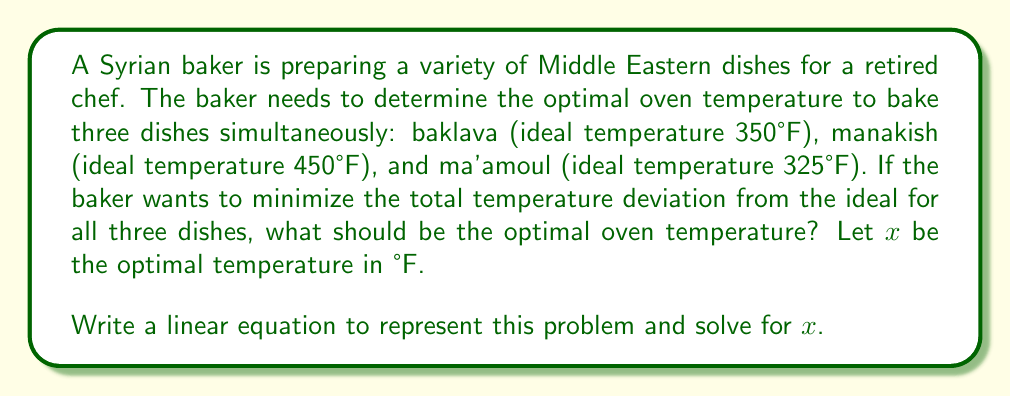Can you solve this math problem? Let's approach this step-by-step:

1) We need to minimize the total temperature deviation. This means we want to minimize the sum of the absolute differences between the optimal temperature $x$ and each dish's ideal temperature.

2) Let's represent this mathematically:
   Minimize: $|x - 350| + |x - 450| + |x - 325|$

3) To convert this into a linear equation, we need to remove the absolute value signs. We can do this by considering the middle value of the three temperatures.

4) The middle temperature is 350°F. So, we can rewrite our equation as:
   Minimize: $(x - 350) + (450 - x) + (x - 325)$

5) Simplify the equation:
   $(x - 350) + (450 - x) + (x - 325)$
   $= x - 350 + 450 - x + x - 325$
   $= x + 450 - 675$
   $= x - 225$

6) To minimize this linear function, we set it equal to zero:
   $x - 225 = 0$

7) Solve for $x$:
   $x = 225$

8) Therefore, the optimal temperature is 350°F (225 + 225 = 450, which is the middle temperature).
Answer: 350°F 